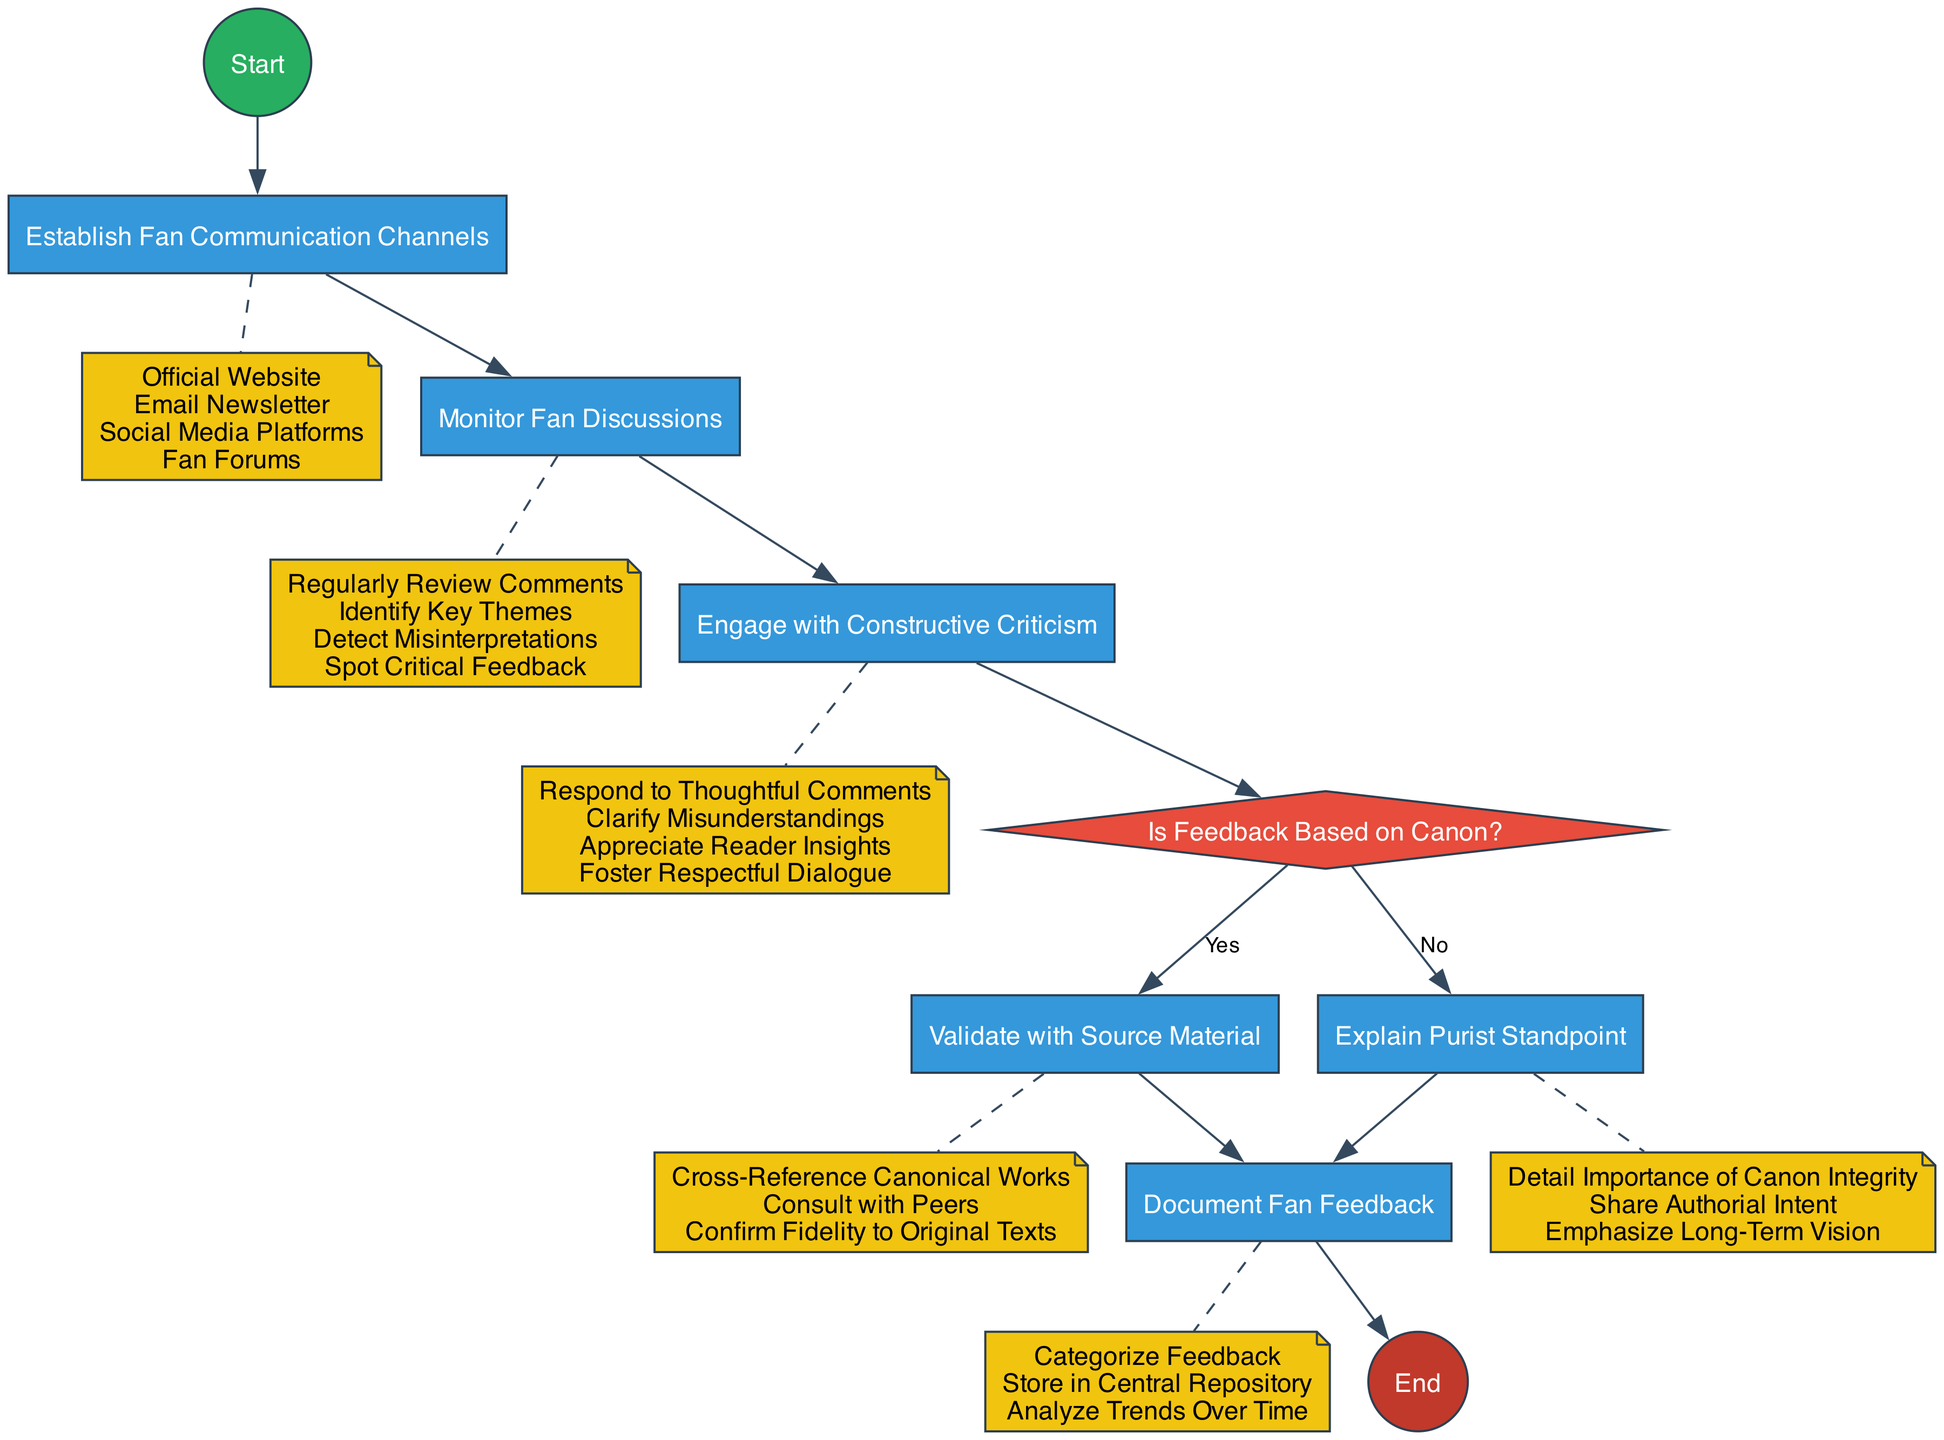What is the first activity in the diagram? The first activity is established by tracing the flow from the start node to the next node, which is clearly marked as "Establish Fan Communication Channels."
Answer: Establish Fan Communication Channels How many activities are present in the diagram? Counting the activity nodes within the diagram shows there are a total of five activities listed: "Establish Fan Communication Channels," "Monitor Fan Discussions," "Engage with Constructive Criticism," "Validate with Source Material," and "Explain Purist Standpoint."
Answer: Five What decision point is present in the diagram? The decision point can be identified by looking for a diamond-shaped node in the diagram, which is labeled "Is Feedback Based on Canon?"
Answer: Is Feedback Based on Canon? What happens if feedback is based on canon? If feedback is based on canon, the flow proceeds from the decision node, taking the 'Yes' branch to the next activity, which is "Validate with Source Material."
Answer: Validate with Source Material What does the "Document Fan Feedback" activity involve? This activity includes categorizing feedback, storing it in a central repository, and analyzing trends over time, as indicated by its detailed note connected to the activity.
Answer: Categorize Feedback, Store in Central Repository, Analyze Trends Over Time How many branches follow the decision node? Upon examining the decision node, it is clear that there are two branches: one leading to "Validate with Source Material" for the 'Yes' response and another leading to "Explain Purist Standpoint" for the 'No' response.
Answer: Two What is the final node in the diagram? The final node can be determined by following the flow from all activities until there are no more connections, which leads to the end node marked "End Fan Interaction Management."
Answer: End Fan Interaction Management What is the purpose of the "Engage with Constructive Criticism" activity? This activity aims to foster interaction by responding to thoughtful comments, clarifying misunderstandings, appreciating reader insights, and fostering respectful dialogue, as detailed in the note connected to this activity.
Answer: Respond to Thoughtful Comments, Clarify Misunderstandings, Appreciate Reader Insights, Foster Respectful Dialogue How does feedback categorized as "No" relate to the main goal of the diagram? Feedback categorized as "No" leads to explaining the purist standpoint, indicating that the management process acknowledges and addresses feedback not rooted in canonical references, reflecting a commitment to canon integrity and authorial intent.
Answer: Explain Purist Standpoint 